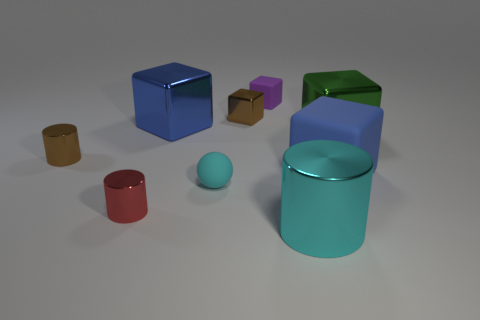How many cyan matte objects have the same size as the brown shiny cylinder?
Your answer should be very brief. 1. There is a large thing on the left side of the small matte sphere; what is its color?
Keep it short and to the point. Blue. How many other objects are the same size as the ball?
Offer a very short reply. 4. What size is the rubber thing that is in front of the brown cylinder and on the left side of the large matte block?
Keep it short and to the point. Small. There is a small matte cube; is it the same color as the big cube on the left side of the large metallic cylinder?
Make the answer very short. No. Are there any large green matte objects that have the same shape as the red object?
Keep it short and to the point. No. What number of things are large cylinders or cyan objects that are in front of the red thing?
Provide a succinct answer. 1. What number of other objects are the same material as the large green thing?
Give a very brief answer. 5. What number of objects are green metal objects or large blue things?
Provide a short and direct response. 3. Are there more cyan things that are on the left side of the small brown block than blue shiny things right of the tiny cyan rubber sphere?
Give a very brief answer. Yes. 